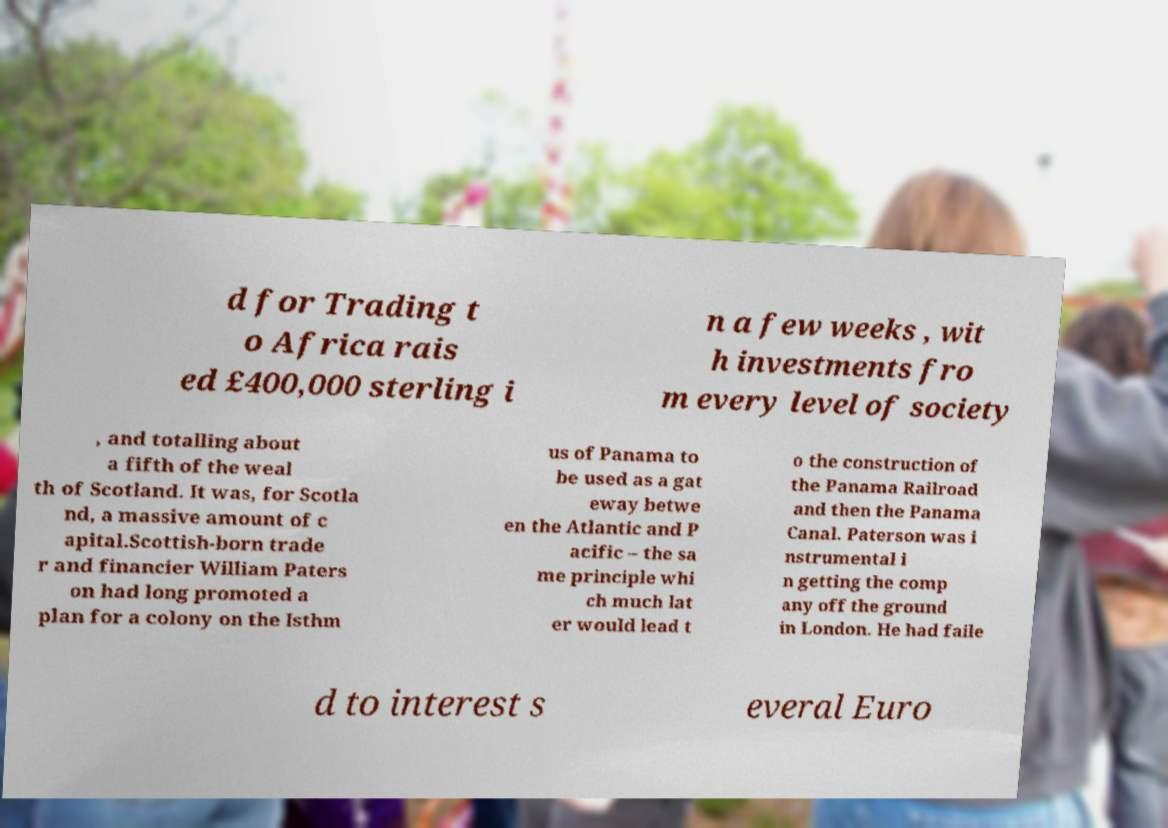Please read and relay the text visible in this image. What does it say? d for Trading t o Africa rais ed £400,000 sterling i n a few weeks , wit h investments fro m every level of society , and totalling about a fifth of the weal th of Scotland. It was, for Scotla nd, a massive amount of c apital.Scottish-born trade r and financier William Paters on had long promoted a plan for a colony on the Isthm us of Panama to be used as a gat eway betwe en the Atlantic and P acific – the sa me principle whi ch much lat er would lead t o the construction of the Panama Railroad and then the Panama Canal. Paterson was i nstrumental i n getting the comp any off the ground in London. He had faile d to interest s everal Euro 